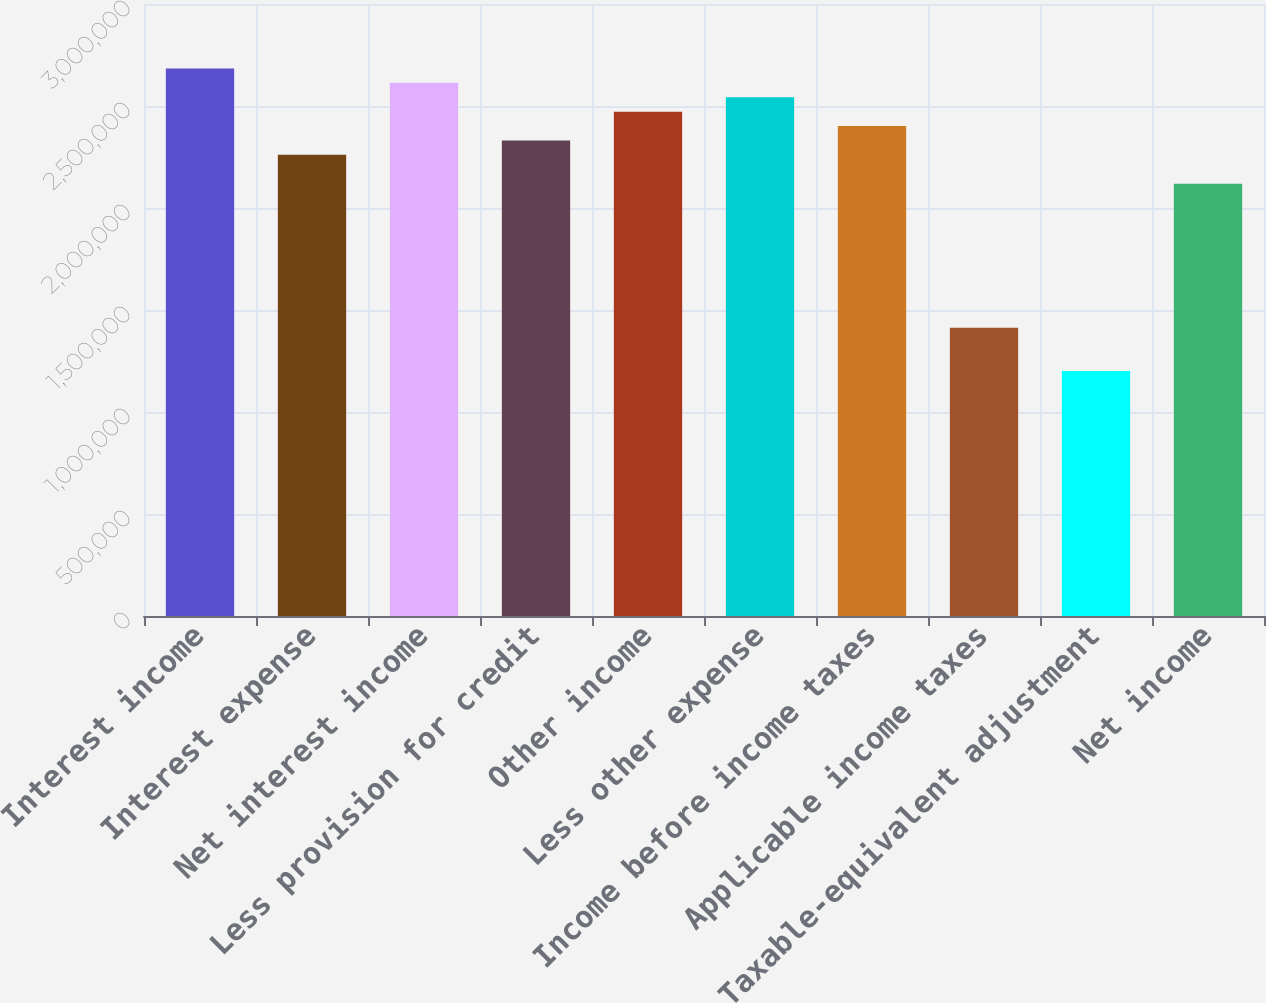<chart> <loc_0><loc_0><loc_500><loc_500><bar_chart><fcel>Interest income<fcel>Interest expense<fcel>Net interest income<fcel>Less provision for credit<fcel>Other income<fcel>Less other expense<fcel>Income before income taxes<fcel>Applicable income taxes<fcel>Taxable-equivalent adjustment<fcel>Net income<nl><fcel>2.68427e+06<fcel>2.26044e+06<fcel>2.61363e+06<fcel>2.33108e+06<fcel>2.47236e+06<fcel>2.54299e+06<fcel>2.40172e+06<fcel>1.41278e+06<fcel>1.20086e+06<fcel>2.11916e+06<nl></chart> 